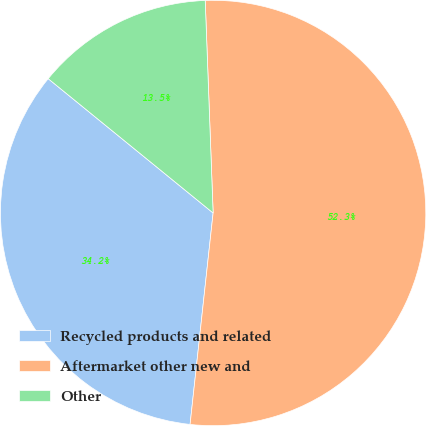<chart> <loc_0><loc_0><loc_500><loc_500><pie_chart><fcel>Recycled products and related<fcel>Aftermarket other new and<fcel>Other<nl><fcel>34.15%<fcel>52.32%<fcel>13.53%<nl></chart> 